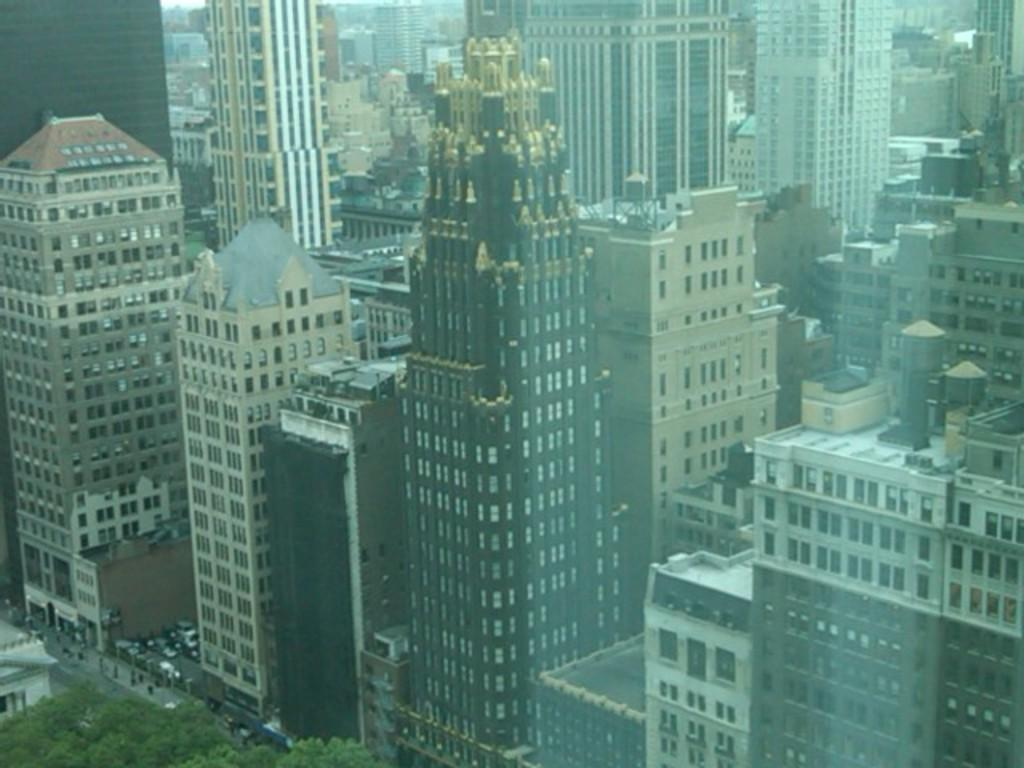What structures can be seen in the image? There are buildings in the image. Where are the trees located in the image? The trees are in the bottom left of the image. What disease is affecting the buildings in the image? There is no indication of any disease affecting the buildings in the image. 